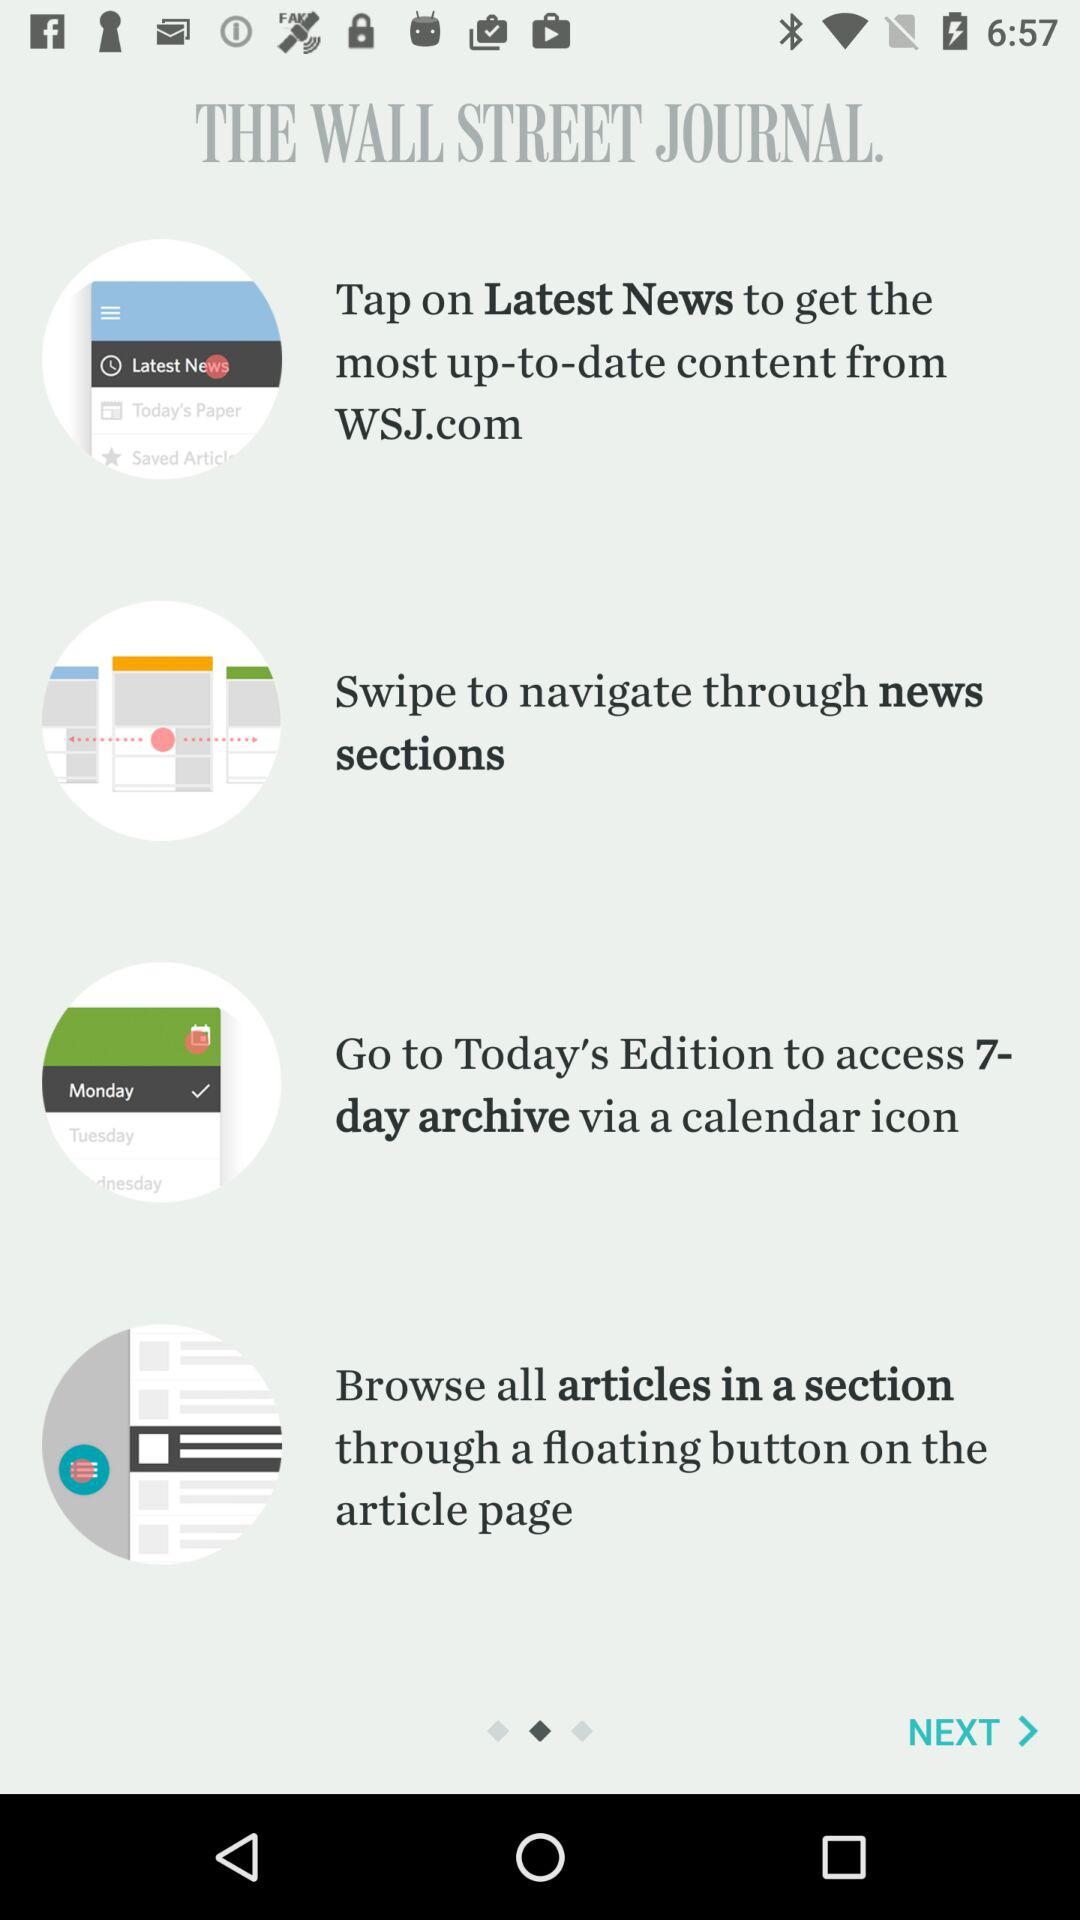How many tabs are there at the bottom of the screen?
Answer the question using a single word or phrase. 3 